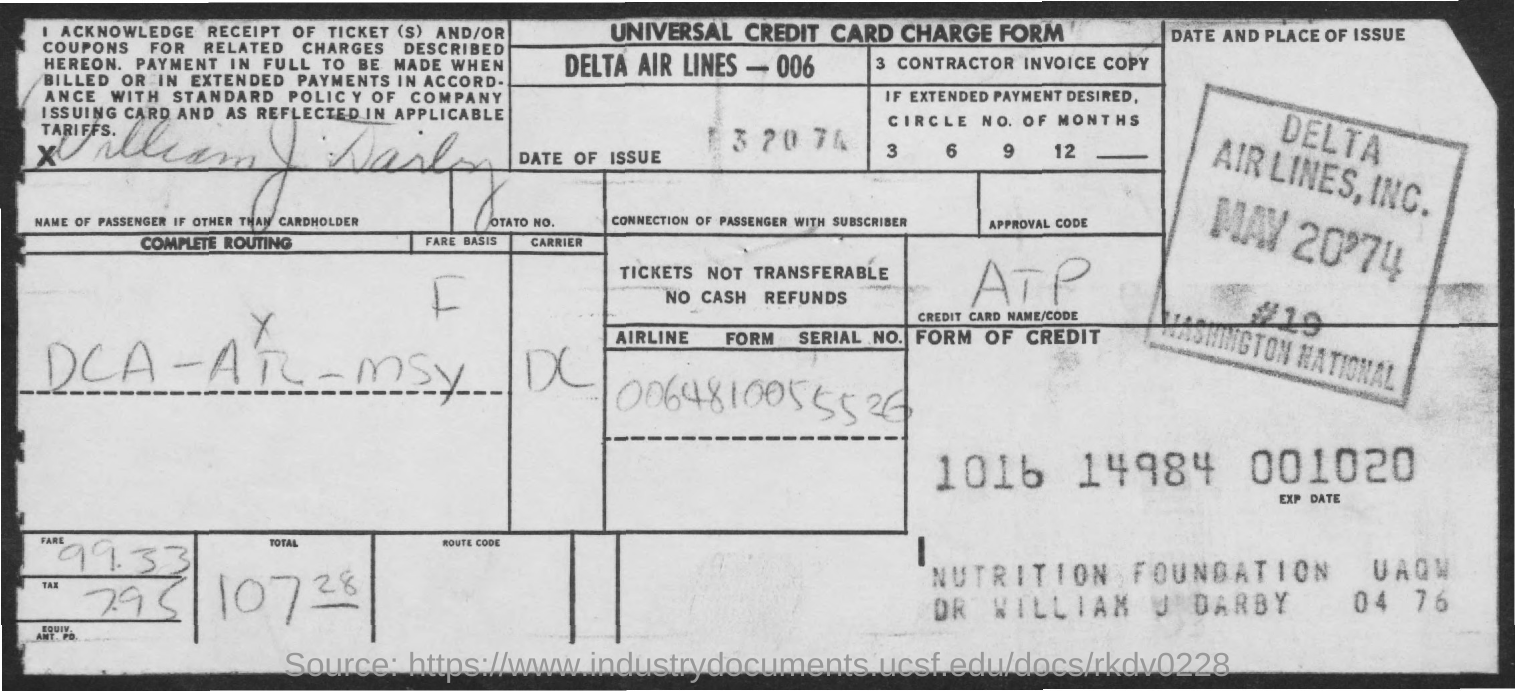What is the name of form given?
Give a very brief answer. Universal credit card charge form. What is the name of airlines?
Offer a terse response. Delta Air Lines - 006. 